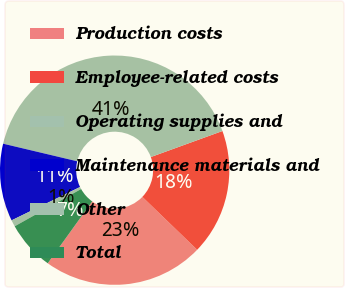Convert chart. <chart><loc_0><loc_0><loc_500><loc_500><pie_chart><fcel>Production costs<fcel>Employee-related costs<fcel>Operating supplies and<fcel>Maintenance materials and<fcel>Other<fcel>Total<nl><fcel>22.7%<fcel>17.76%<fcel>40.74%<fcel>10.92%<fcel>0.93%<fcel>6.94%<nl></chart> 